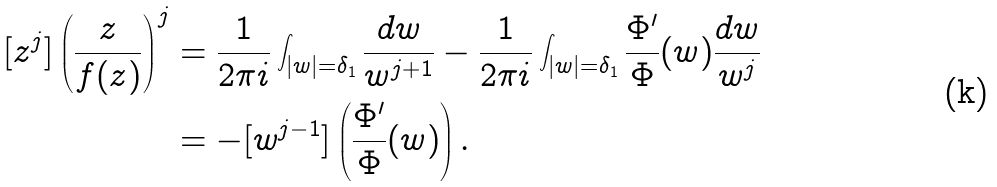<formula> <loc_0><loc_0><loc_500><loc_500>[ z ^ { j } ] \left ( \frac { z } { f ( z ) } \right ) ^ { j } & = \frac { 1 } { 2 \pi i } \int _ { | w | = \delta _ { 1 } } \frac { d w } { w ^ { j + 1 } } - \frac { 1 } { 2 \pi i } \int _ { | w | = \delta _ { 1 } } \frac { \Phi ^ { \prime } } { \Phi } ( w ) \frac { d w } { w ^ { j } } \\ & = - [ w ^ { j - 1 } ] \left ( \frac { \Phi ^ { \prime } } { \Phi } ( w ) \right ) .</formula> 